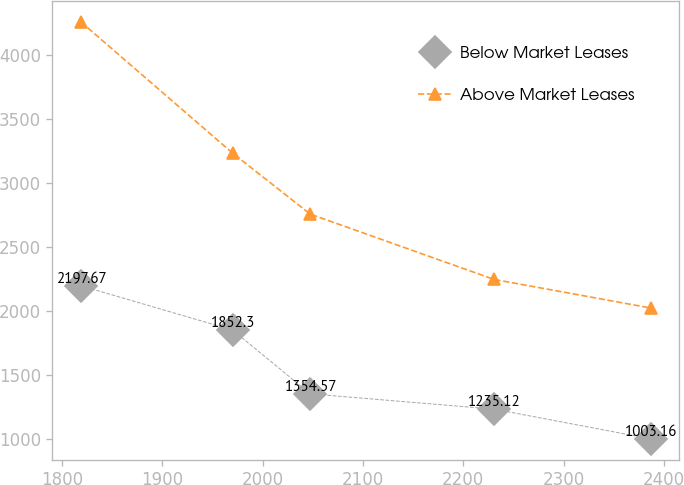Convert chart to OTSL. <chart><loc_0><loc_0><loc_500><loc_500><line_chart><ecel><fcel>Below Market Leases<fcel>Above Market Leases<nl><fcel>1819.11<fcel>2197.67<fcel>4255.96<nl><fcel>1970.16<fcel>1852.3<fcel>3232.7<nl><fcel>2047.44<fcel>1354.57<fcel>2757.12<nl><fcel>2230.65<fcel>1235.12<fcel>2247.21<nl><fcel>2386.84<fcel>1003.16<fcel>2024.02<nl></chart> 